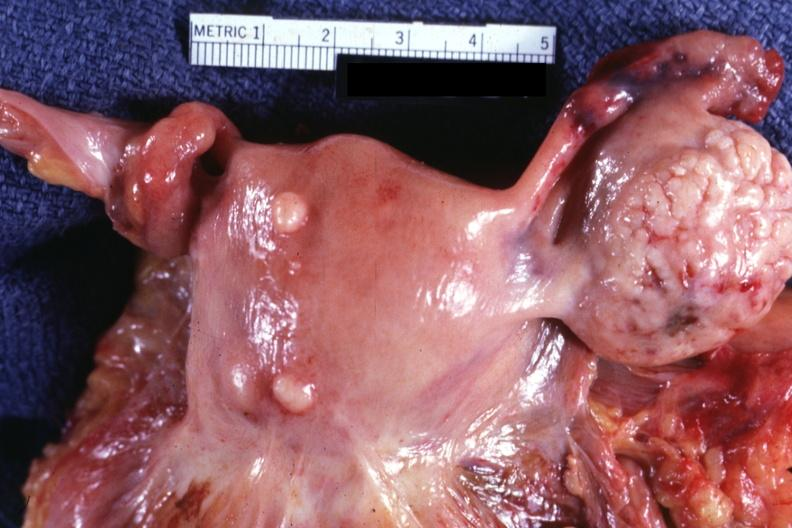what is normal ovary in?
Answer the question using a single word or phrase. In photo 